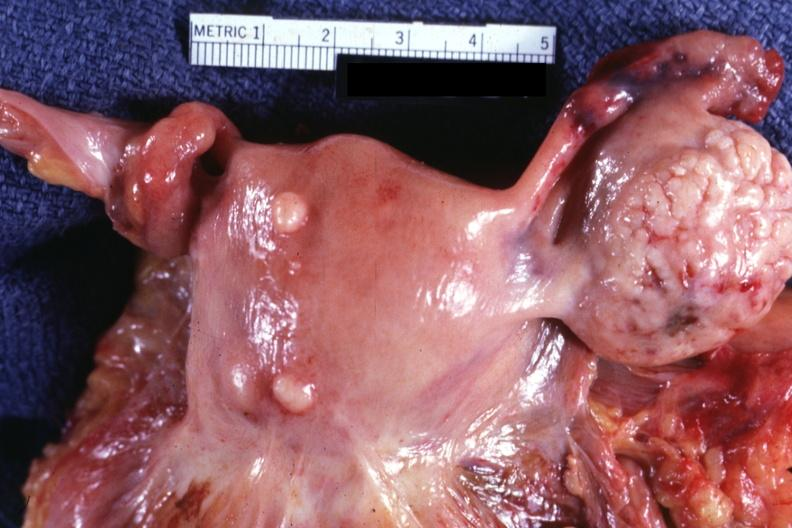what is normal ovary in?
Answer the question using a single word or phrase. In photo 